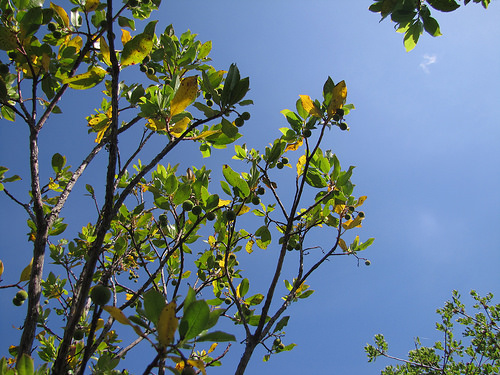<image>
Is there a sky to the left of the leave? No. The sky is not to the left of the leave. From this viewpoint, they have a different horizontal relationship. 